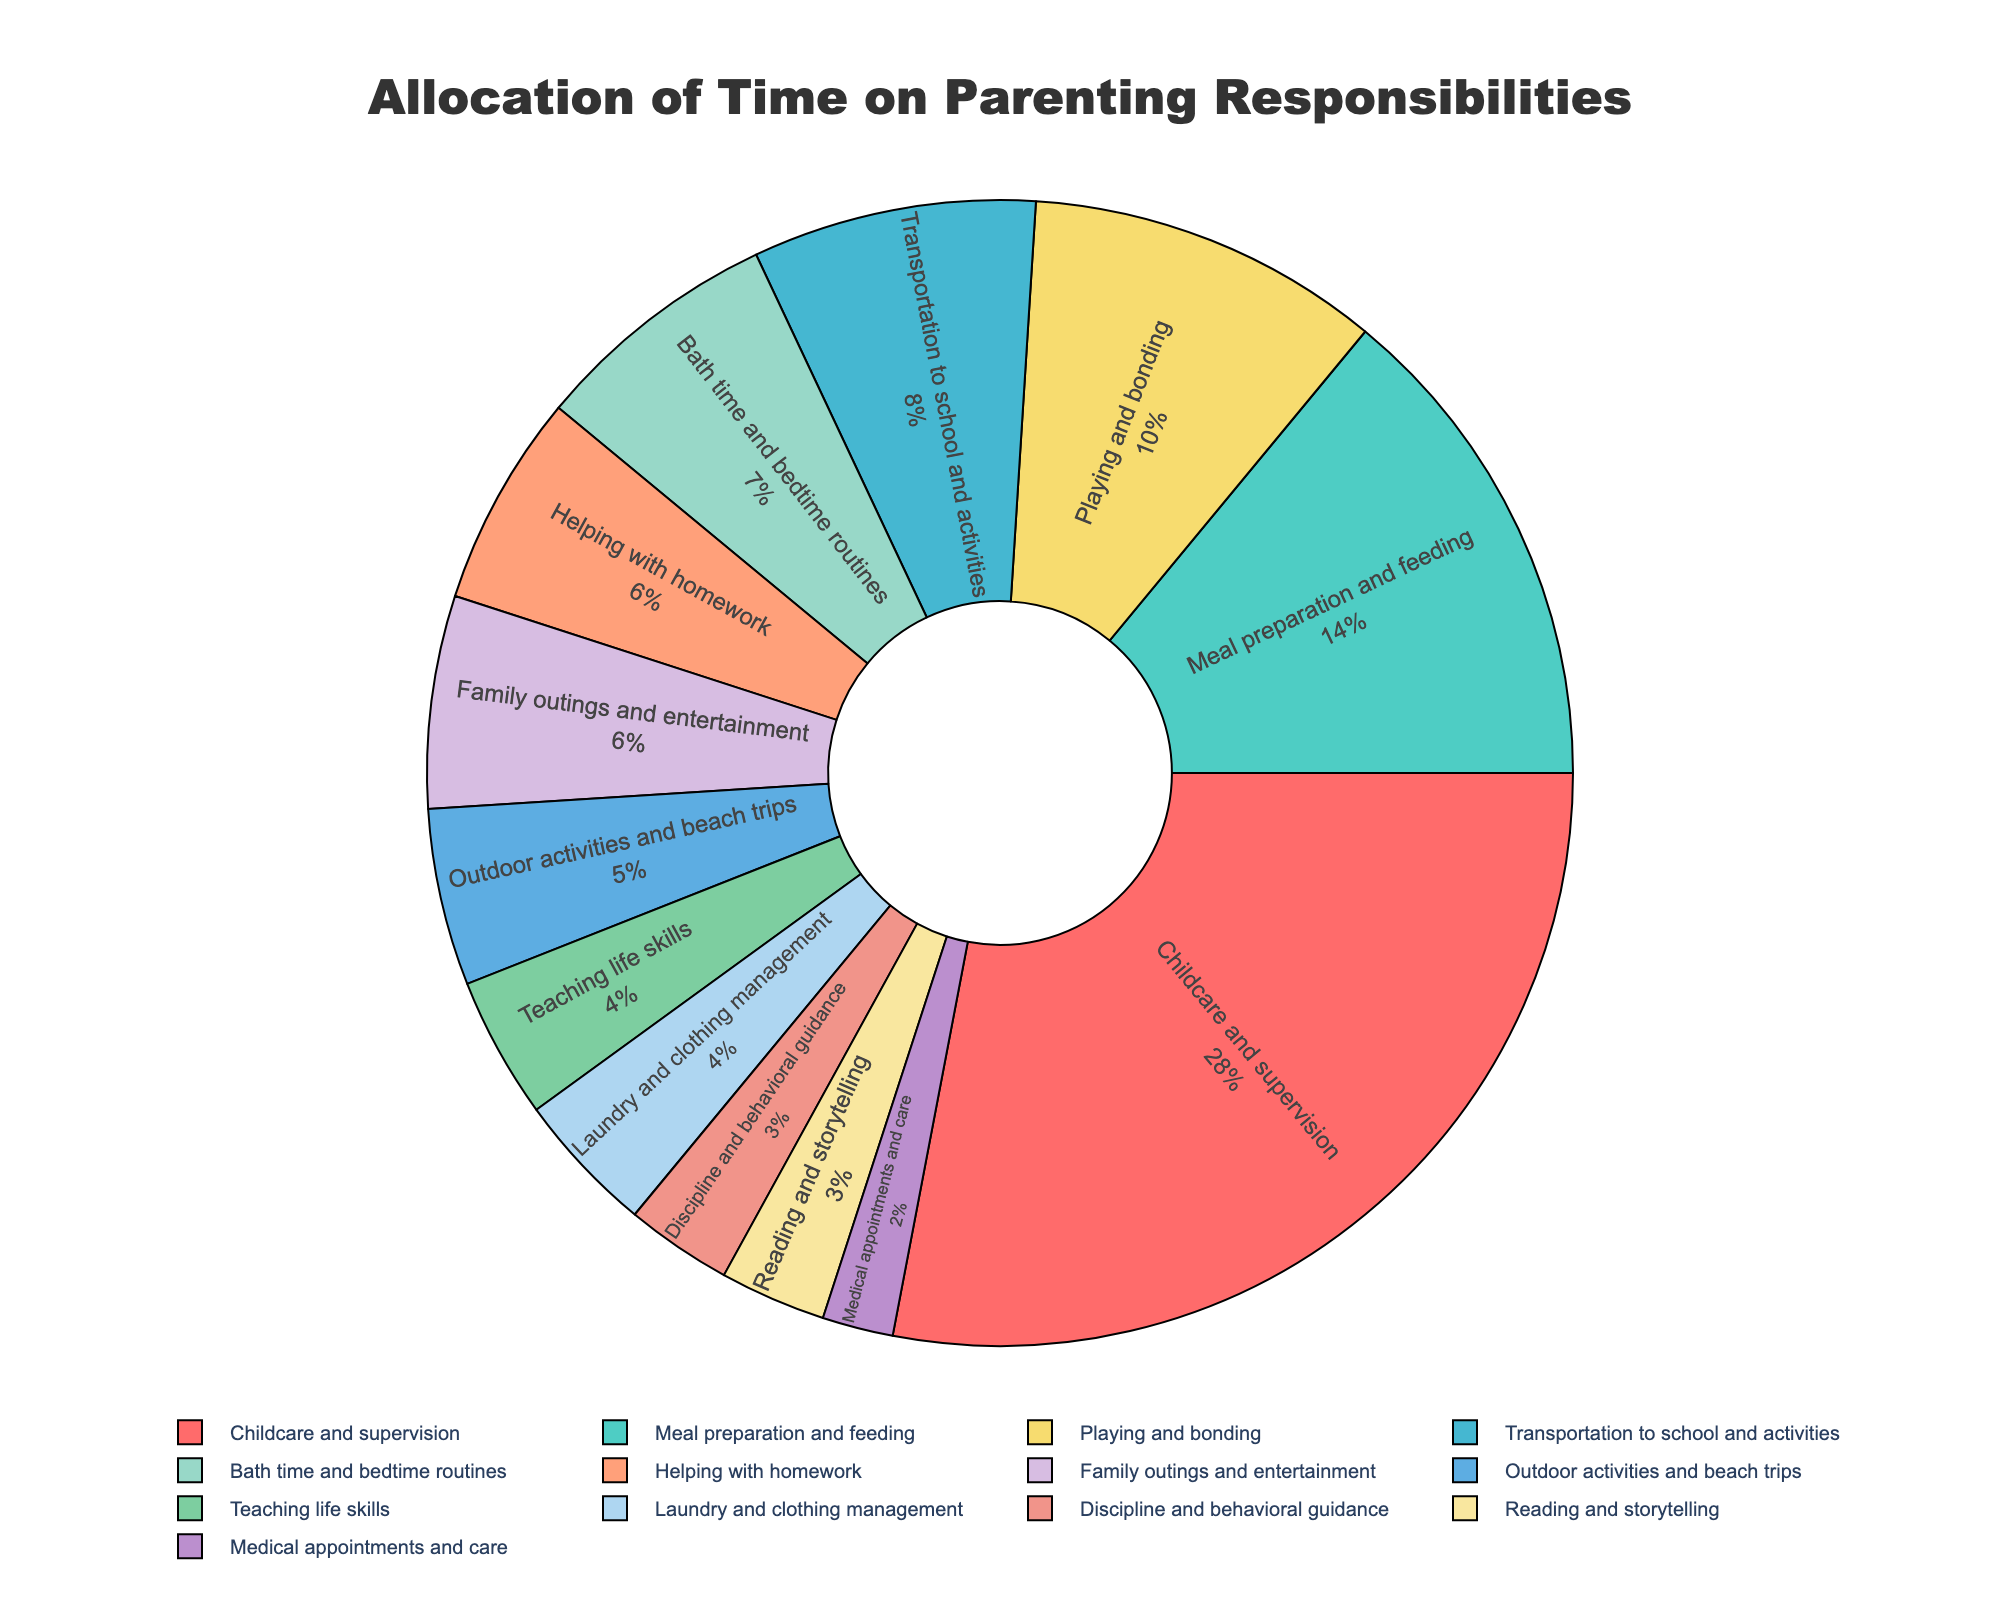Which activity takes up the most amount of time each week? The largest slice of the pie chart represents the activity that takes up the most amount of time, which is labeled "Childcare and supervision" with 28 hours.
Answer: Childcare and supervision How many hours are spent on meal preparation and feeding relative to transportation to school and activities? The pie chart shows 14 hours for meal preparation and feeding and 8 hours for transportation to school and activities. The difference is 14 - 8 = 6 hours.
Answer: 6 hours What percentage of total time is spent on playing and bonding? The pie chart portion labeled "Playing and bonding" indicates the percentage, which is calculated as (10 hours / sum of all hours) * 100%. The total hours are 100, so (10/100)*100% = 10%.
Answer: 10% How do the hours spent on family outings compare to the hours spent on bath time and bedtime routines? The pie chart shows family outings take 6 hours and bath time and bedtime routines take 7 hours. So, 6 hours < 7 hours.
Answer: Bath time and bedtime routines take more time What is the combined time spent on outdoor activities and beach trips and reading and storytelling? The pie chart shows 5 hours for outdoor activities and beach trips and 3 hours for reading and storytelling. The sum is 5 + 3 = 8 hours.
Answer: 8 hours Which activity has the least amount of time allocated? The smallest slice of the pie chart represents the activity with the least amount of time, which is "Medical appointments and care" with 2 hours.
Answer: Medical appointments and care What is the total weekly time spent on activities related to education (helping with homework and teaching life skills)? The pie chart shows 6 hours for helping with homework and 4 hours for teaching life skills. The total time is 6 + 4 = 10 hours.
Answer: 10 hours Is there more time allocated to discipline and behavioral guidance or to teaching life skills? The pie chart shows 3 hours for discipline and behavioral guidance and 4 hours for teaching life skills. 3 hours < 4 hours.
Answer: Teaching life skills Which activity is represented by a pink color on the pie chart? The pink portion of the pie chart corresponds to "Childcare and supervision".
Answer: Childcare and supervision 